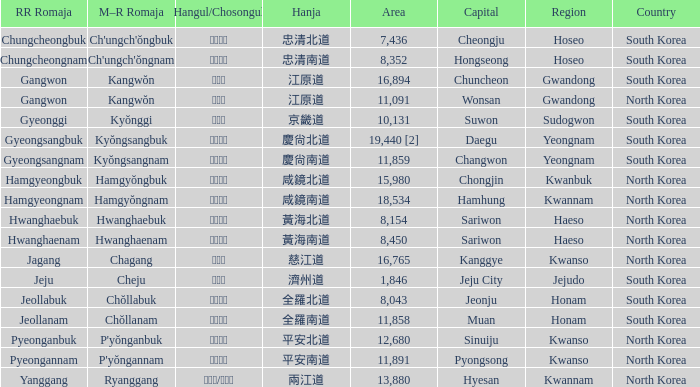What country is home to a city that has the hanja 平安北道? North Korea. 